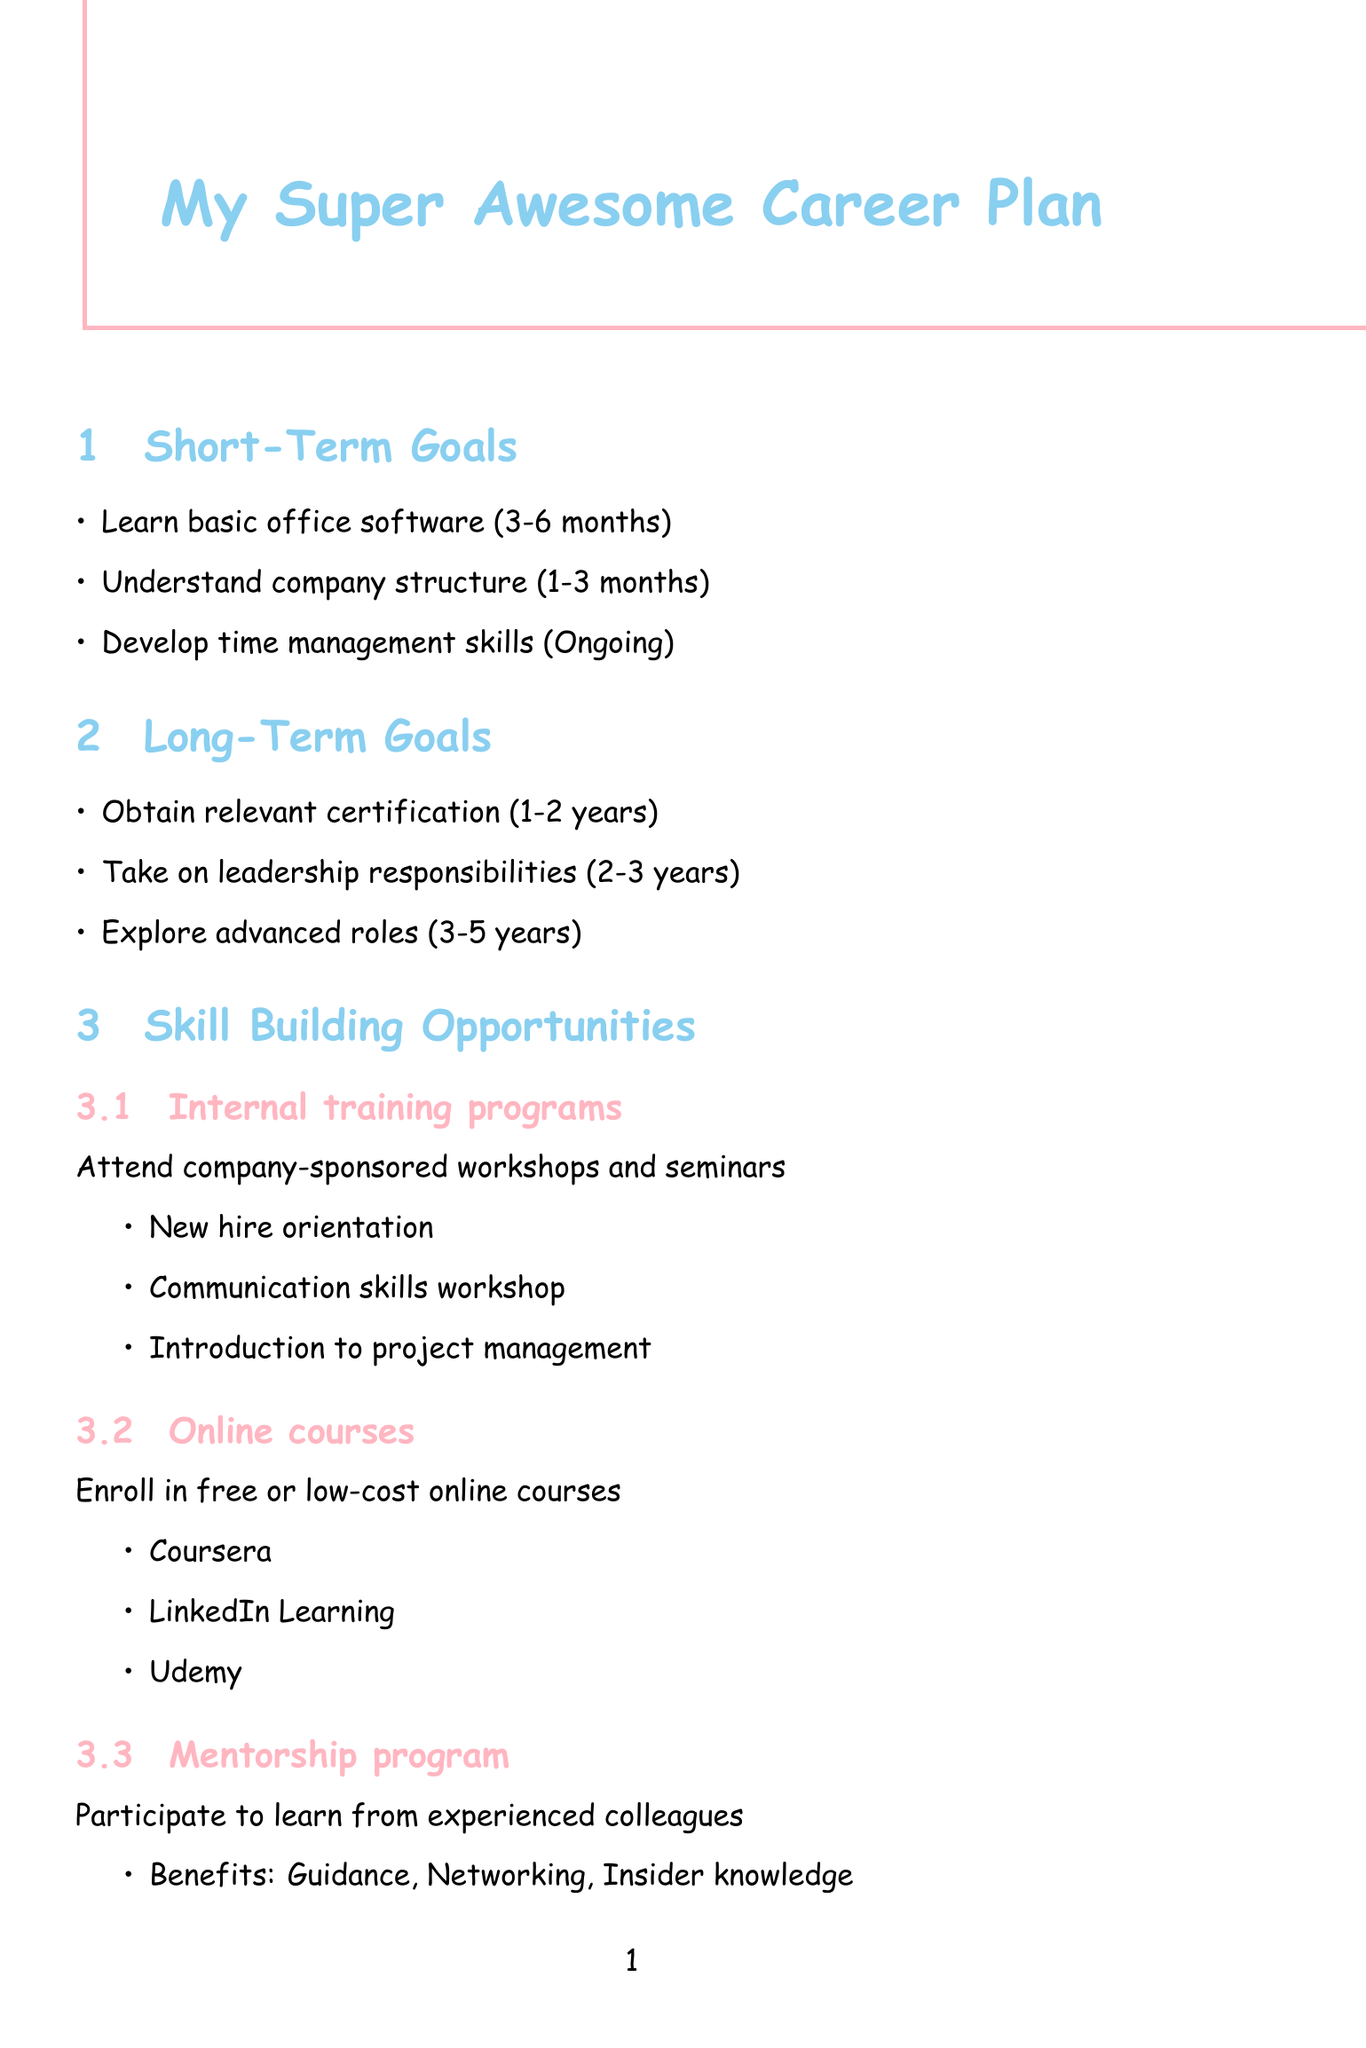what is the timeframe for learning basic office software? The timeframe for learning basic office software is specified in the short-term goals section of the document as 3-6 months.
Answer: 3-6 months what are two examples of internal training programs? The document mentions specific examples of internal training programs under the skill-building opportunities section. Two examples are New hire orientation and Communication skills workshop.
Answer: New hire orientation, Communication skills workshop what is one skill required for the path from Customer Service Representative to Team Lead? The required skills for advancing from Customer Service Representative to Team Lead are listed in the potential career paths section. One skill is Communication.
Answer: Communication how long is the mentorship program expected to last? The document does not specify a duration for the mentorship program, it is inferred that the program is ongoing and based on the needs of participants.
Answer: Ongoing which company resource offers financial assistance for education? The company resources section outlines various resources, specifying that the Tuition Reimbursement Program provides financial assistance for education.
Answer: Tuition Reimbursement Program what is one challenge mentioned for new employees? The document identifies several challenges faced by new employees. One challenge mentioned is Imposter syndrome.
Answer: Imposter syndrome how many long-term goals are stated in the document? The long-term goals section of the document lists three specific goals, answering how many long-term goals are stated.
Answer: Three what timeframe is suggested for obtaining relevant certification? The document provides specific timeframes for each long-term goal, indicating that obtaining relevant certification should take 1-2 years.
Answer: 1-2 years what is one example of an online course platform mentioned? The document provides examples of platforms where online courses can be taken under the skill-building opportunities section, with one example being Coursera.
Answer: Coursera 